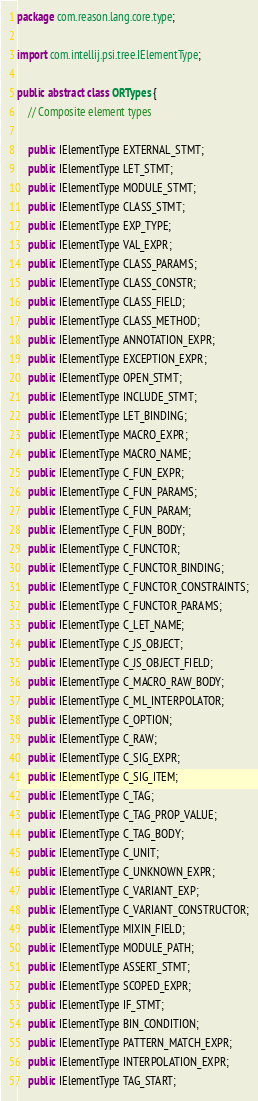<code> <loc_0><loc_0><loc_500><loc_500><_Java_>package com.reason.lang.core.type;

import com.intellij.psi.tree.IElementType;

public abstract class ORTypes {
    // Composite element types

    public IElementType EXTERNAL_STMT;
    public IElementType LET_STMT;
    public IElementType MODULE_STMT;
    public IElementType CLASS_STMT;
    public IElementType EXP_TYPE;
    public IElementType VAL_EXPR;
    public IElementType CLASS_PARAMS;
    public IElementType CLASS_CONSTR;
    public IElementType CLASS_FIELD;
    public IElementType CLASS_METHOD;
    public IElementType ANNOTATION_EXPR;
    public IElementType EXCEPTION_EXPR;
    public IElementType OPEN_STMT;
    public IElementType INCLUDE_STMT;
    public IElementType LET_BINDING;
    public IElementType MACRO_EXPR;
    public IElementType MACRO_NAME;
    public IElementType C_FUN_EXPR;
    public IElementType C_FUN_PARAMS;
    public IElementType C_FUN_PARAM;
    public IElementType C_FUN_BODY;
    public IElementType C_FUNCTOR;
    public IElementType C_FUNCTOR_BINDING;
    public IElementType C_FUNCTOR_CONSTRAINTS;
    public IElementType C_FUNCTOR_PARAMS;
    public IElementType C_LET_NAME;
    public IElementType C_JS_OBJECT;
    public IElementType C_JS_OBJECT_FIELD;
    public IElementType C_MACRO_RAW_BODY;
    public IElementType C_ML_INTERPOLATOR;
    public IElementType C_OPTION;
    public IElementType C_RAW;
    public IElementType C_SIG_EXPR;
    public IElementType C_SIG_ITEM;
    public IElementType C_TAG;
    public IElementType C_TAG_PROP_VALUE;
    public IElementType C_TAG_BODY;
    public IElementType C_UNIT;
    public IElementType C_UNKNOWN_EXPR;
    public IElementType C_VARIANT_EXP;
    public IElementType C_VARIANT_CONSTRUCTOR;
    public IElementType MIXIN_FIELD;
    public IElementType MODULE_PATH;
    public IElementType ASSERT_STMT;
    public IElementType SCOPED_EXPR;
    public IElementType IF_STMT;
    public IElementType BIN_CONDITION;
    public IElementType PATTERN_MATCH_EXPR;
    public IElementType INTERPOLATION_EXPR;
    public IElementType TAG_START;</code> 